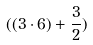<formula> <loc_0><loc_0><loc_500><loc_500>( ( 3 \cdot 6 ) + \frac { 3 } { 2 } )</formula> 